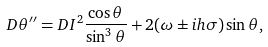<formula> <loc_0><loc_0><loc_500><loc_500>D \theta ^ { \prime \prime } = D I ^ { 2 } \frac { \cos \theta } { \sin ^ { 3 } \theta } + 2 ( \omega \pm i h \sigma ) \sin \theta ,</formula> 